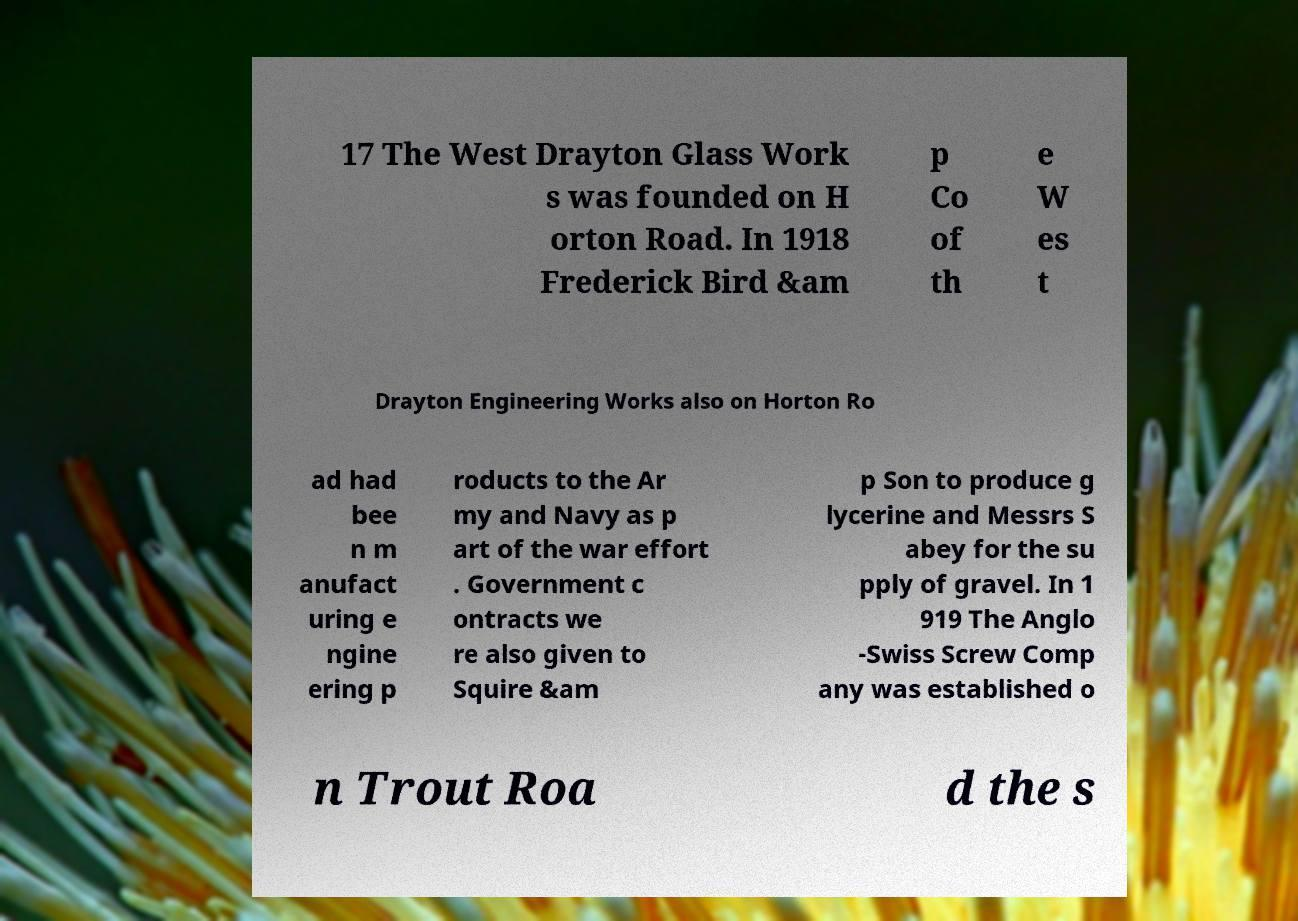Please read and relay the text visible in this image. What does it say? 17 The West Drayton Glass Work s was founded on H orton Road. In 1918 Frederick Bird &am p Co of th e W es t Drayton Engineering Works also on Horton Ro ad had bee n m anufact uring e ngine ering p roducts to the Ar my and Navy as p art of the war effort . Government c ontracts we re also given to Squire &am p Son to produce g lycerine and Messrs S abey for the su pply of gravel. In 1 919 The Anglo -Swiss Screw Comp any was established o n Trout Roa d the s 